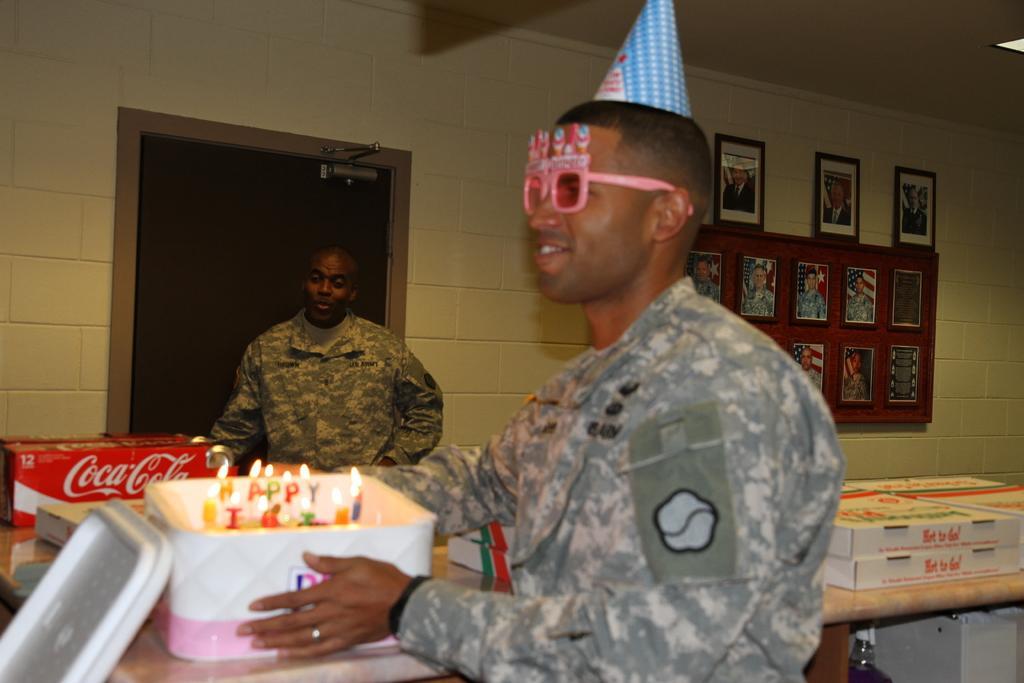In one or two sentences, can you explain what this image depicts? In this image we can see a man on the right side and he is smiling. Here we can see a birthday cap on his head. He is holding a cake in his hands. Here we can see another person. Here we can see packed boxes on the table and they are on the right side. Here we can see the photo frames on the wall. 